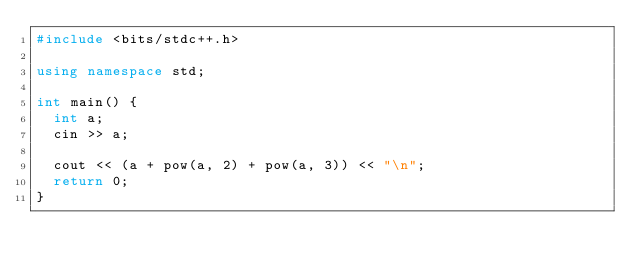<code> <loc_0><loc_0><loc_500><loc_500><_C++_>#include <bits/stdc++.h>

using namespace std;

int main() {
  int a;
  cin >> a;
  
  cout << (a + pow(a, 2) + pow(a, 3)) << "\n";
  return 0;
}</code> 